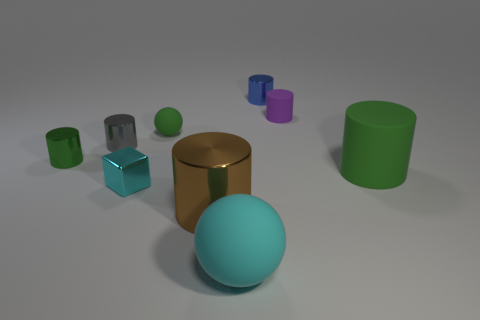Are there an equal number of small balls behind the green ball and big objects?
Your response must be concise. No. Is there any other thing that is the same size as the blue cylinder?
Offer a very short reply. Yes. What material is the purple object that is the same shape as the brown metal thing?
Your answer should be very brief. Rubber. There is a rubber thing left of the big cylinder on the left side of the purple rubber cylinder; what shape is it?
Provide a short and direct response. Sphere. Do the green cylinder right of the small purple thing and the tiny cyan thing have the same material?
Give a very brief answer. No. Are there the same number of big cyan matte spheres that are in front of the small cyan shiny thing and cyan balls that are on the right side of the small blue metal thing?
Make the answer very short. No. There is a thing that is the same color as the large matte sphere; what is its material?
Give a very brief answer. Metal. There is a small green thing that is on the left side of the tiny gray metallic cylinder; what number of metallic cylinders are left of it?
Your response must be concise. 0. There is a tiny matte object in front of the purple rubber thing; is its color the same as the big thing that is behind the cyan metal block?
Offer a terse response. Yes. What material is the green object that is the same size as the cyan rubber thing?
Give a very brief answer. Rubber. 